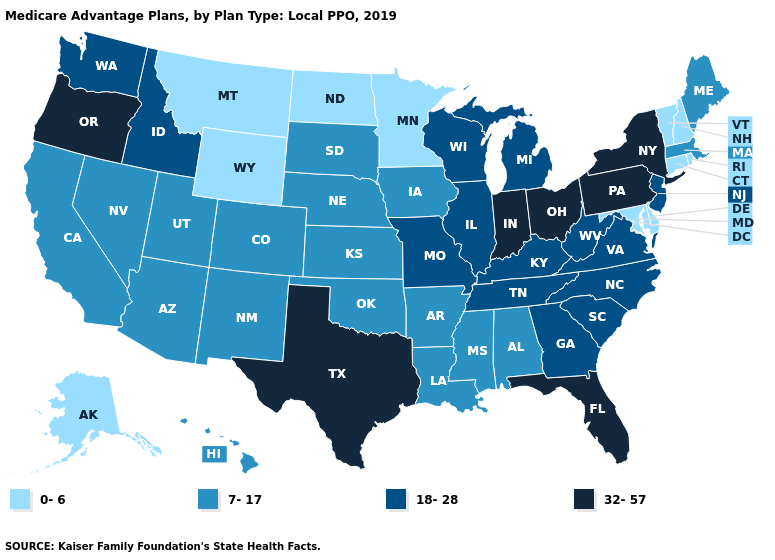What is the value of Hawaii?
Short answer required. 7-17. Does Hawaii have a higher value than Georgia?
Write a very short answer. No. Name the states that have a value in the range 7-17?
Short answer required. Alabama, Arizona, Arkansas, California, Colorado, Hawaii, Iowa, Kansas, Louisiana, Maine, Massachusetts, Mississippi, Nebraska, Nevada, New Mexico, Oklahoma, South Dakota, Utah. Which states have the highest value in the USA?
Short answer required. Florida, Indiana, New York, Ohio, Oregon, Pennsylvania, Texas. What is the lowest value in the Northeast?
Short answer required. 0-6. What is the highest value in the West ?
Keep it brief. 32-57. Which states have the lowest value in the USA?
Concise answer only. Alaska, Connecticut, Delaware, Maryland, Minnesota, Montana, New Hampshire, North Dakota, Rhode Island, Vermont, Wyoming. Does Arizona have the lowest value in the USA?
Concise answer only. No. What is the value of Virginia?
Concise answer only. 18-28. Name the states that have a value in the range 18-28?
Give a very brief answer. Georgia, Idaho, Illinois, Kentucky, Michigan, Missouri, New Jersey, North Carolina, South Carolina, Tennessee, Virginia, Washington, West Virginia, Wisconsin. Name the states that have a value in the range 0-6?
Quick response, please. Alaska, Connecticut, Delaware, Maryland, Minnesota, Montana, New Hampshire, North Dakota, Rhode Island, Vermont, Wyoming. What is the value of New York?
Concise answer only. 32-57. What is the value of Maine?
Short answer required. 7-17. Does the map have missing data?
Short answer required. No. 